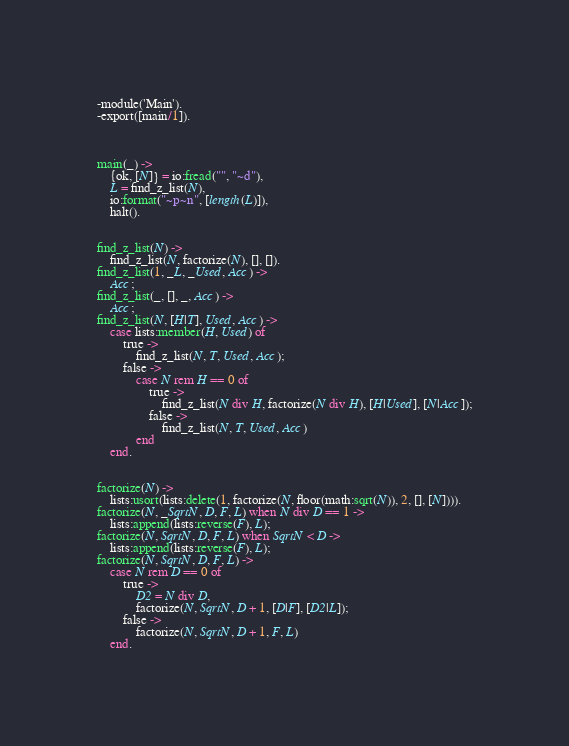<code> <loc_0><loc_0><loc_500><loc_500><_Erlang_>-module('Main').
-export([main/1]).



main(_) ->
    {ok, [N]} = io:fread("", "~d"),
    L = find_z_list(N),
    io:format("~p~n", [length(L)]),
    halt().


find_z_list(N) ->
    find_z_list(N, factorize(N), [], []).
find_z_list(1, _L, _Used, Acc) ->
    Acc;
find_z_list(_, [], _, Acc) ->
    Acc;
find_z_list(N, [H|T], Used, Acc) ->
    case lists:member(H, Used) of
        true ->
            find_z_list(N, T, Used, Acc);
        false ->
            case N rem H == 0 of
                true ->
                    find_z_list(N div H, factorize(N div H), [H|Used], [N|Acc]);
                false ->
                    find_z_list(N, T, Used, Acc)
            end
    end.


factorize(N) ->
    lists:usort(lists:delete(1, factorize(N, floor(math:sqrt(N)), 2, [], [N]))).
factorize(N, _SqrtN, D, F, L) when N div D == 1 ->
    lists:append(lists:reverse(F), L);
factorize(N, SqrtN, D, F, L) when SqrtN < D ->
    lists:append(lists:reverse(F), L);
factorize(N, SqrtN, D, F, L) ->
    case N rem D == 0 of
        true ->
            D2 = N div D,
            factorize(N, SqrtN, D + 1, [D|F], [D2|L]);
        false ->
            factorize(N, SqrtN, D + 1, F, L)
    end.
</code> 